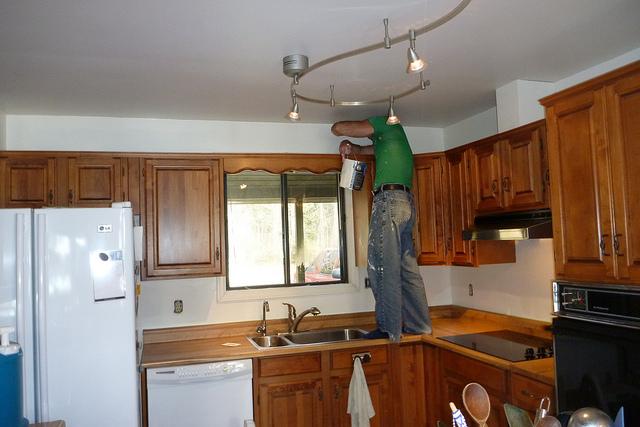What color are the cabinets?
Give a very brief answer. Brown. What is this man doing?
Answer briefly. Painting. Does the man have a head?
Be succinct. Yes. 